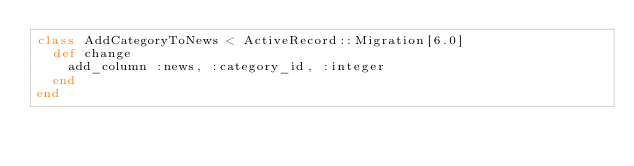Convert code to text. <code><loc_0><loc_0><loc_500><loc_500><_Ruby_>class AddCategoryToNews < ActiveRecord::Migration[6.0]
  def change
    add_column :news, :category_id, :integer
  end
end
</code> 